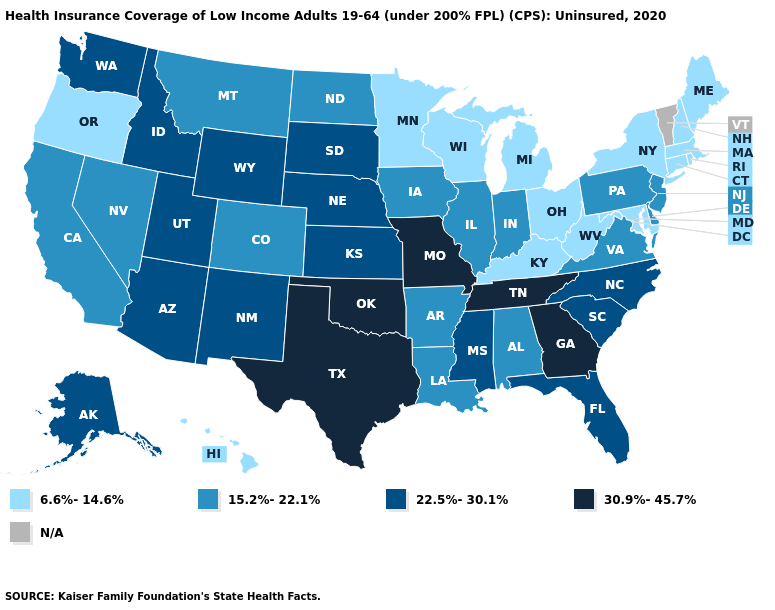Among the states that border Florida , which have the lowest value?
Quick response, please. Alabama. Does the first symbol in the legend represent the smallest category?
Concise answer only. Yes. What is the value of Colorado?
Concise answer only. 15.2%-22.1%. Does the map have missing data?
Concise answer only. Yes. What is the value of Colorado?
Short answer required. 15.2%-22.1%. Which states hav the highest value in the West?
Give a very brief answer. Alaska, Arizona, Idaho, New Mexico, Utah, Washington, Wyoming. Name the states that have a value in the range N/A?
Answer briefly. Vermont. Does Maine have the lowest value in the USA?
Be succinct. Yes. Does the first symbol in the legend represent the smallest category?
Keep it brief. Yes. Name the states that have a value in the range 30.9%-45.7%?
Write a very short answer. Georgia, Missouri, Oklahoma, Tennessee, Texas. What is the value of Missouri?
Be succinct. 30.9%-45.7%. What is the lowest value in states that border New Jersey?
Write a very short answer. 6.6%-14.6%. Name the states that have a value in the range 30.9%-45.7%?
Be succinct. Georgia, Missouri, Oklahoma, Tennessee, Texas. How many symbols are there in the legend?
Be succinct. 5. 